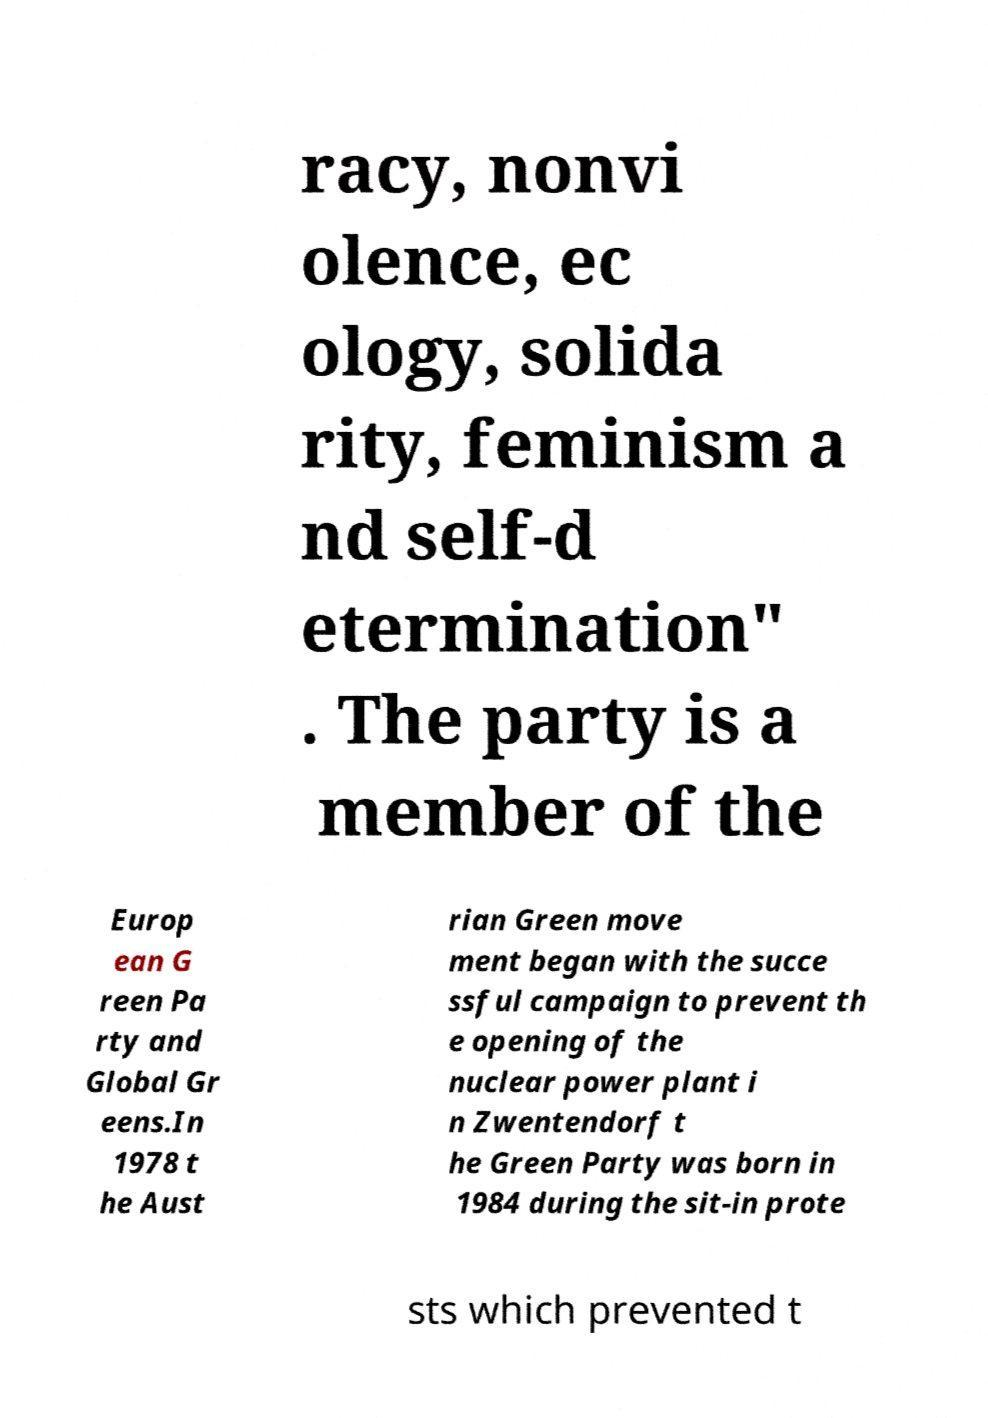For documentation purposes, I need the text within this image transcribed. Could you provide that? racy, nonvi olence, ec ology, solida rity, feminism a nd self-d etermination" . The party is a member of the Europ ean G reen Pa rty and Global Gr eens.In 1978 t he Aust rian Green move ment began with the succe ssful campaign to prevent th e opening of the nuclear power plant i n Zwentendorf t he Green Party was born in 1984 during the sit-in prote sts which prevented t 